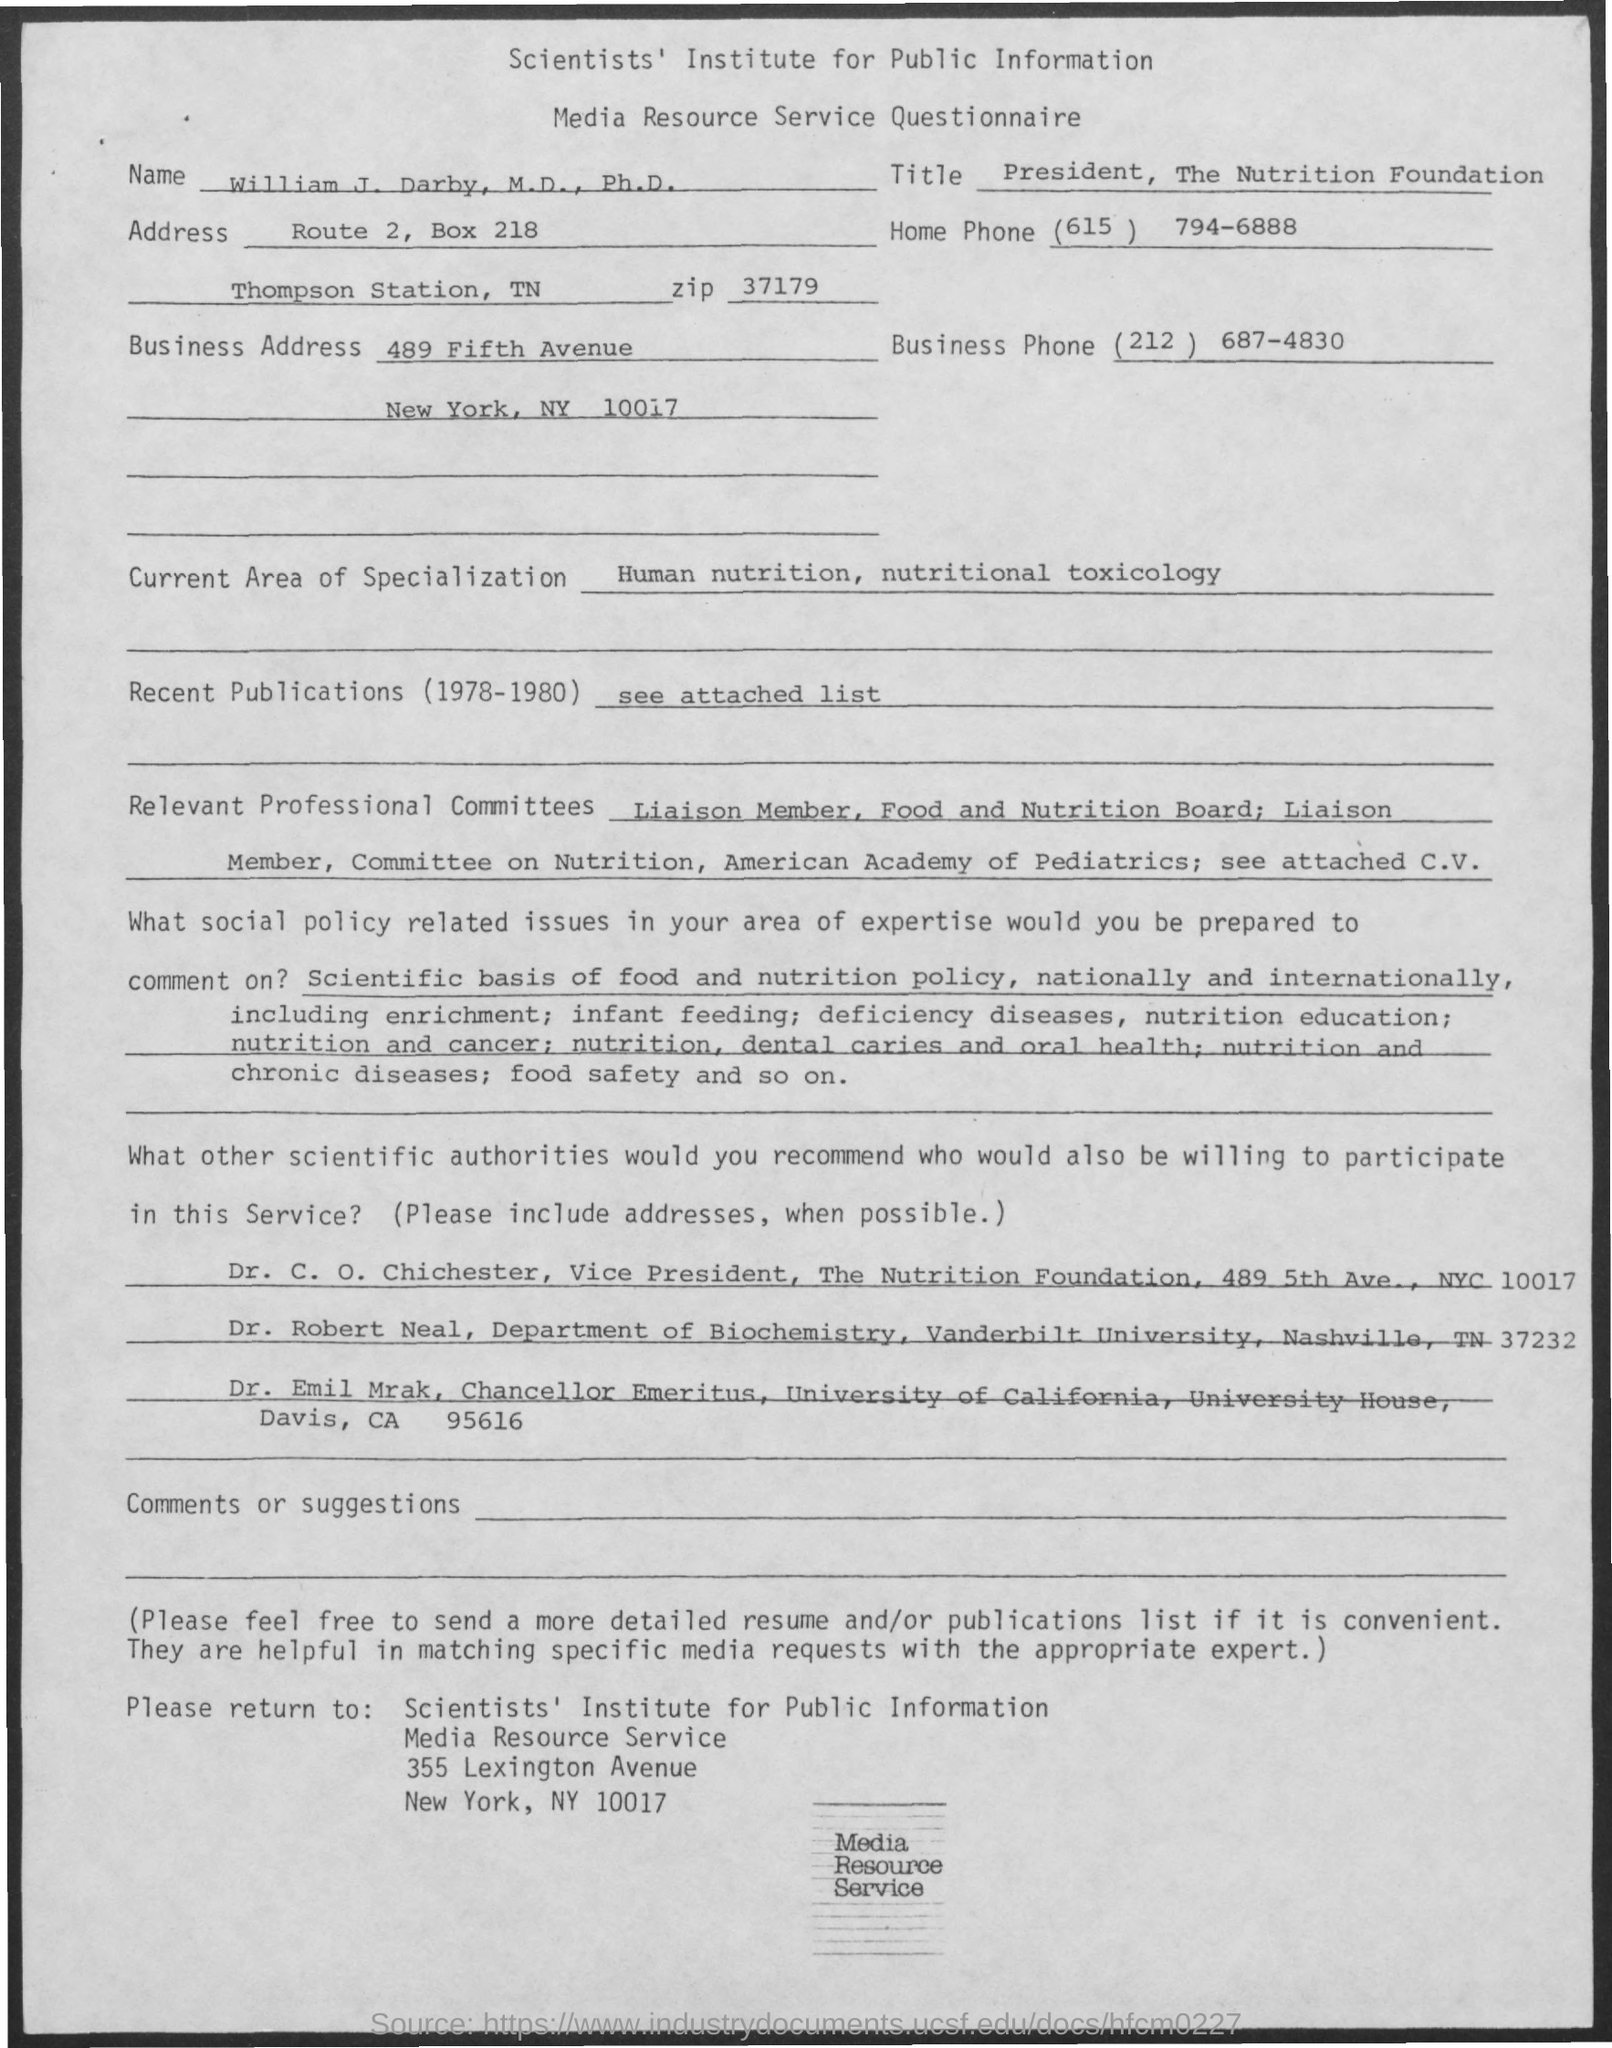What is the Title of the document?
Make the answer very short. Media Resource Service Questionnaire. What is the Title?
Your response must be concise. President, The Nutrition Foundation. What is the Home Phone?
Provide a short and direct response. (615) 794-6888. What is the Business Phone?
Your response must be concise. (212) 687-4830. 